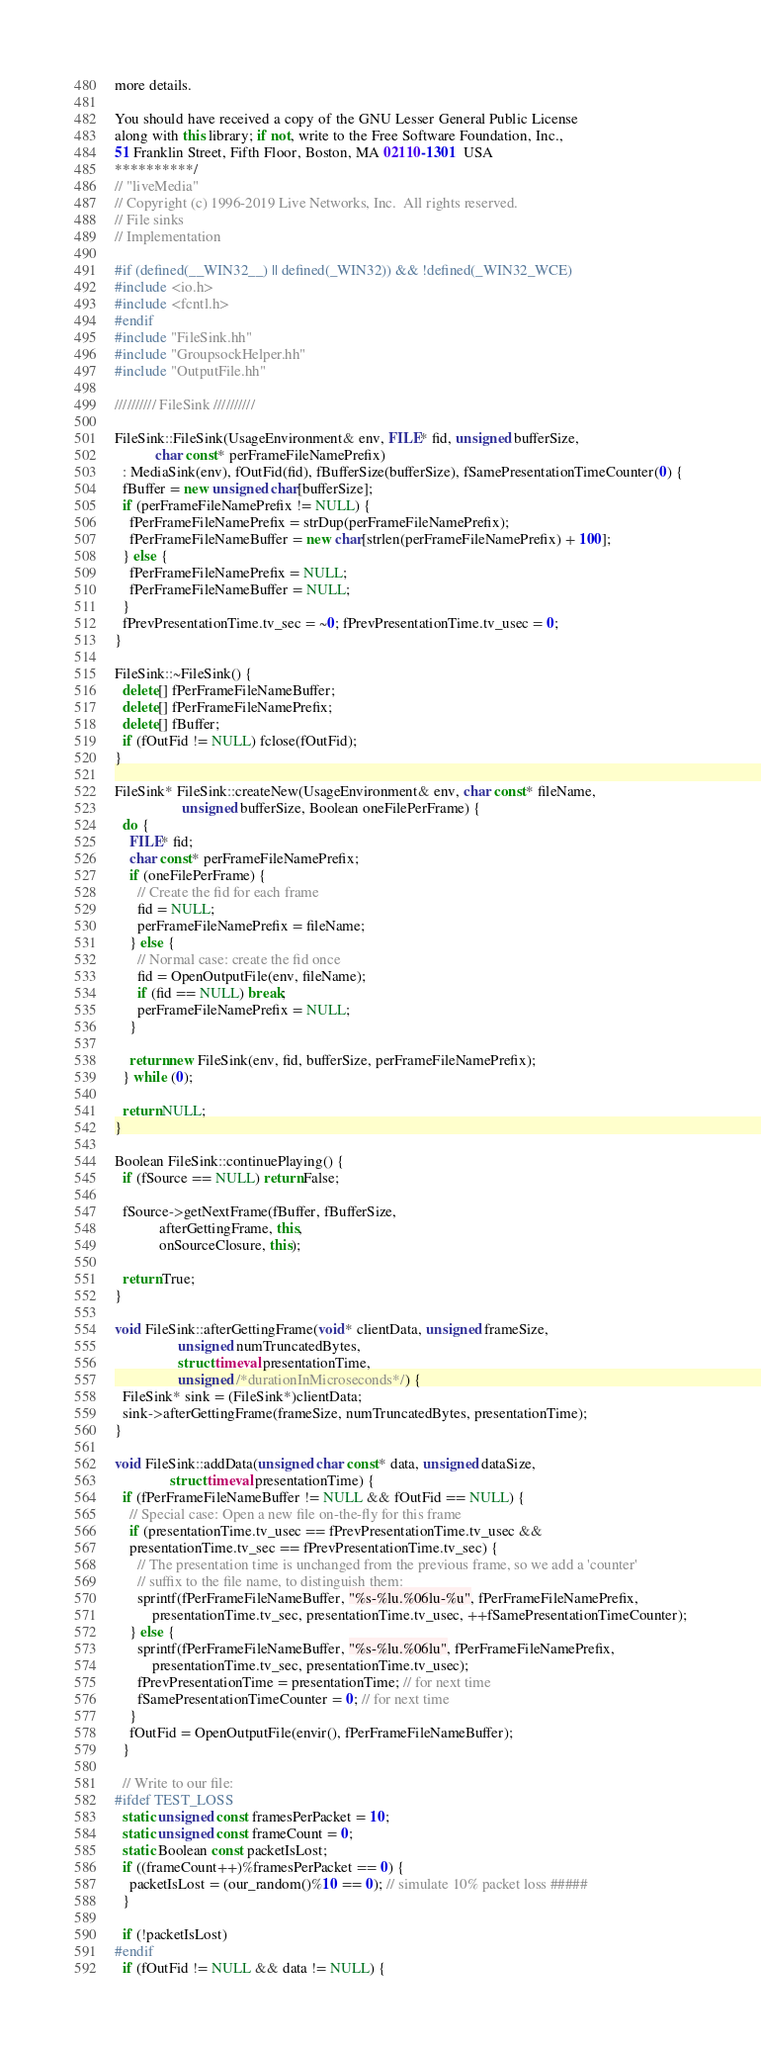Convert code to text. <code><loc_0><loc_0><loc_500><loc_500><_C++_>more details.

You should have received a copy of the GNU Lesser General Public License
along with this library; if not, write to the Free Software Foundation, Inc.,
51 Franklin Street, Fifth Floor, Boston, MA 02110-1301  USA
**********/
// "liveMedia"
// Copyright (c) 1996-2019 Live Networks, Inc.  All rights reserved.
// File sinks
// Implementation

#if (defined(__WIN32__) || defined(_WIN32)) && !defined(_WIN32_WCE)
#include <io.h>
#include <fcntl.h>
#endif
#include "FileSink.hh"
#include "GroupsockHelper.hh"
#include "OutputFile.hh"

////////// FileSink //////////

FileSink::FileSink(UsageEnvironment& env, FILE* fid, unsigned bufferSize,
		   char const* perFrameFileNamePrefix)
  : MediaSink(env), fOutFid(fid), fBufferSize(bufferSize), fSamePresentationTimeCounter(0) {
  fBuffer = new unsigned char[bufferSize];
  if (perFrameFileNamePrefix != NULL) {
    fPerFrameFileNamePrefix = strDup(perFrameFileNamePrefix);
    fPerFrameFileNameBuffer = new char[strlen(perFrameFileNamePrefix) + 100];
  } else {
    fPerFrameFileNamePrefix = NULL;
    fPerFrameFileNameBuffer = NULL;
  }
  fPrevPresentationTime.tv_sec = ~0; fPrevPresentationTime.tv_usec = 0;
}

FileSink::~FileSink() {
  delete[] fPerFrameFileNameBuffer;
  delete[] fPerFrameFileNamePrefix;
  delete[] fBuffer;
  if (fOutFid != NULL) fclose(fOutFid);
}

FileSink* FileSink::createNew(UsageEnvironment& env, char const* fileName,
			      unsigned bufferSize, Boolean oneFilePerFrame) {
  do {
    FILE* fid;
    char const* perFrameFileNamePrefix;
    if (oneFilePerFrame) {
      // Create the fid for each frame
      fid = NULL;
      perFrameFileNamePrefix = fileName;
    } else {
      // Normal case: create the fid once
      fid = OpenOutputFile(env, fileName);
      if (fid == NULL) break;
      perFrameFileNamePrefix = NULL;
    }

    return new FileSink(env, fid, bufferSize, perFrameFileNamePrefix);
  } while (0);

  return NULL;
}

Boolean FileSink::continuePlaying() {
  if (fSource == NULL) return False;

  fSource->getNextFrame(fBuffer, fBufferSize,
			afterGettingFrame, this,
			onSourceClosure, this);

  return True;
}

void FileSink::afterGettingFrame(void* clientData, unsigned frameSize,
				 unsigned numTruncatedBytes,
				 struct timeval presentationTime,
				 unsigned /*durationInMicroseconds*/) {
  FileSink* sink = (FileSink*)clientData;
  sink->afterGettingFrame(frameSize, numTruncatedBytes, presentationTime);
}

void FileSink::addData(unsigned char const* data, unsigned dataSize,
		       struct timeval presentationTime) {
  if (fPerFrameFileNameBuffer != NULL && fOutFid == NULL) {
    // Special case: Open a new file on-the-fly for this frame
    if (presentationTime.tv_usec == fPrevPresentationTime.tv_usec &&
	presentationTime.tv_sec == fPrevPresentationTime.tv_sec) {
      // The presentation time is unchanged from the previous frame, so we add a 'counter'
      // suffix to the file name, to distinguish them:
      sprintf(fPerFrameFileNameBuffer, "%s-%lu.%06lu-%u", fPerFrameFileNamePrefix,
	      presentationTime.tv_sec, presentationTime.tv_usec, ++fSamePresentationTimeCounter);
    } else {
      sprintf(fPerFrameFileNameBuffer, "%s-%lu.%06lu", fPerFrameFileNamePrefix,
	      presentationTime.tv_sec, presentationTime.tv_usec);
      fPrevPresentationTime = presentationTime; // for next time
      fSamePresentationTimeCounter = 0; // for next time
    }
    fOutFid = OpenOutputFile(envir(), fPerFrameFileNameBuffer);
  }

  // Write to our file:
#ifdef TEST_LOSS
  static unsigned const framesPerPacket = 10;
  static unsigned const frameCount = 0;
  static Boolean const packetIsLost;
  if ((frameCount++)%framesPerPacket == 0) {
    packetIsLost = (our_random()%10 == 0); // simulate 10% packet loss #####
  }

  if (!packetIsLost)
#endif
  if (fOutFid != NULL && data != NULL) {</code> 